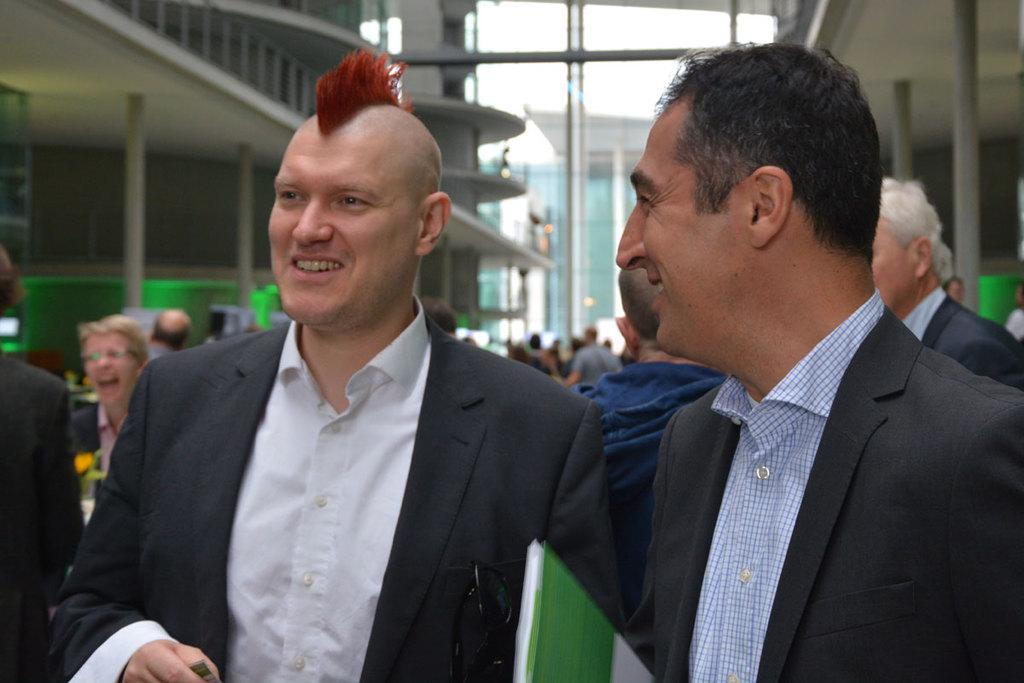Where was the image taken? The image was taken outdoors. What can be seen in the middle of the image? There are two men with smiling faces in the middle of the image. What is visible in the background of the image? There are many people and a few buildings in the background of the image. How many horses are present in the image? There are no horses present in the image. What type of house can be seen in the background of the image? There is no house visible in the background of the image. 